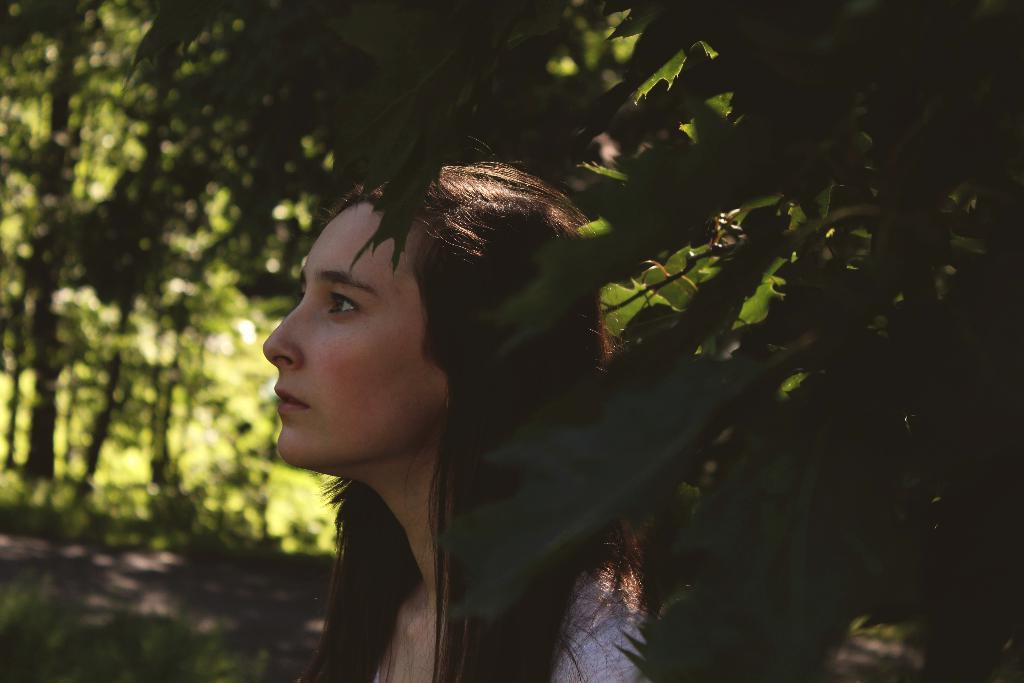What is present in the image? There is a person in the image. What can be seen in the background of the image? There are green trees visible in the background of the image. What type of rifle is the stranger holding in the image? There is no stranger or rifle present in the image; it only features a person and green trees in the background. 